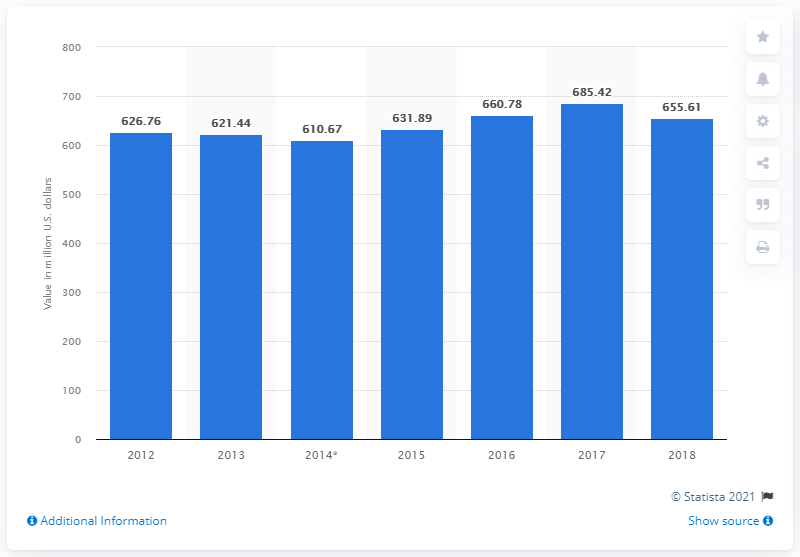What trend can be observed in cocoa exports from Mexico over the years shown in this bar chart? The bar chart displays a fluctuation in the value of cocoa exports over the years, with a noticeable increase in 2015 and 2017, reaching a peak in 2017 before slightly declining in 2018. 